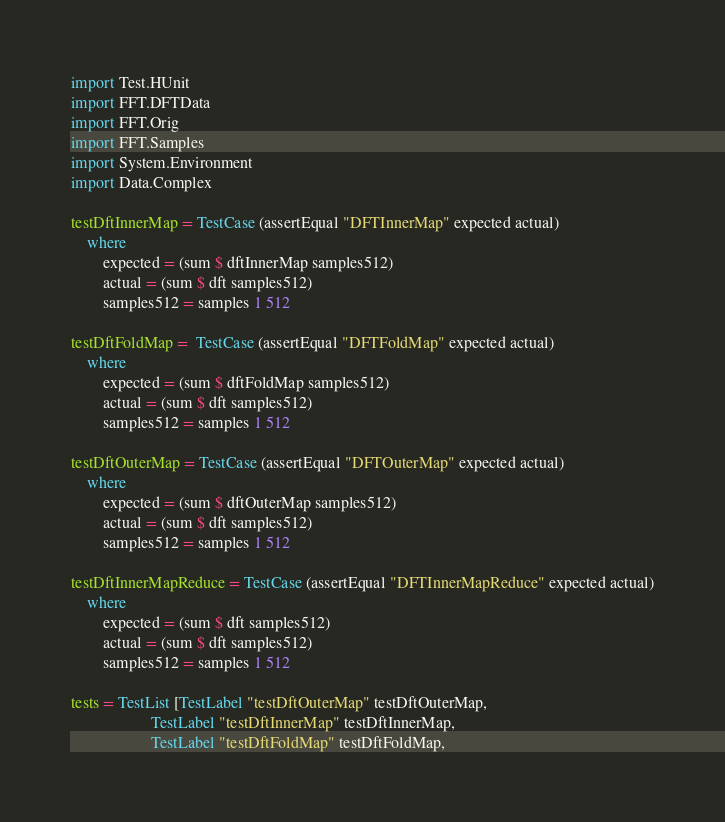Convert code to text. <code><loc_0><loc_0><loc_500><loc_500><_Haskell_>import Test.HUnit
import FFT.DFTData
import FFT.Orig
import FFT.Samples
import System.Environment
import Data.Complex

testDftInnerMap = TestCase (assertEqual "DFTInnerMap" expected actual)
    where
        expected = (sum $ dftInnerMap samples512)
        actual = (sum $ dft samples512)
        samples512 = samples 1 512

testDftFoldMap =  TestCase (assertEqual "DFTFoldMap" expected actual)
    where
        expected = (sum $ dftFoldMap samples512)
        actual = (sum $ dft samples512)
        samples512 = samples 1 512

testDftOuterMap = TestCase (assertEqual "DFTOuterMap" expected actual)
    where
        expected = (sum $ dftOuterMap samples512)
        actual = (sum $ dft samples512)
        samples512 = samples 1 512

testDftInnerMapReduce = TestCase (assertEqual "DFTInnerMapReduce" expected actual)
    where
        expected = (sum $ dft samples512)
        actual = (sum $ dft samples512)
        samples512 = samples 1 512

tests = TestList [TestLabel "testDftOuterMap" testDftOuterMap,
                    TestLabel "testDftInnerMap" testDftInnerMap,
                    TestLabel "testDftFoldMap" testDftFoldMap,</code> 